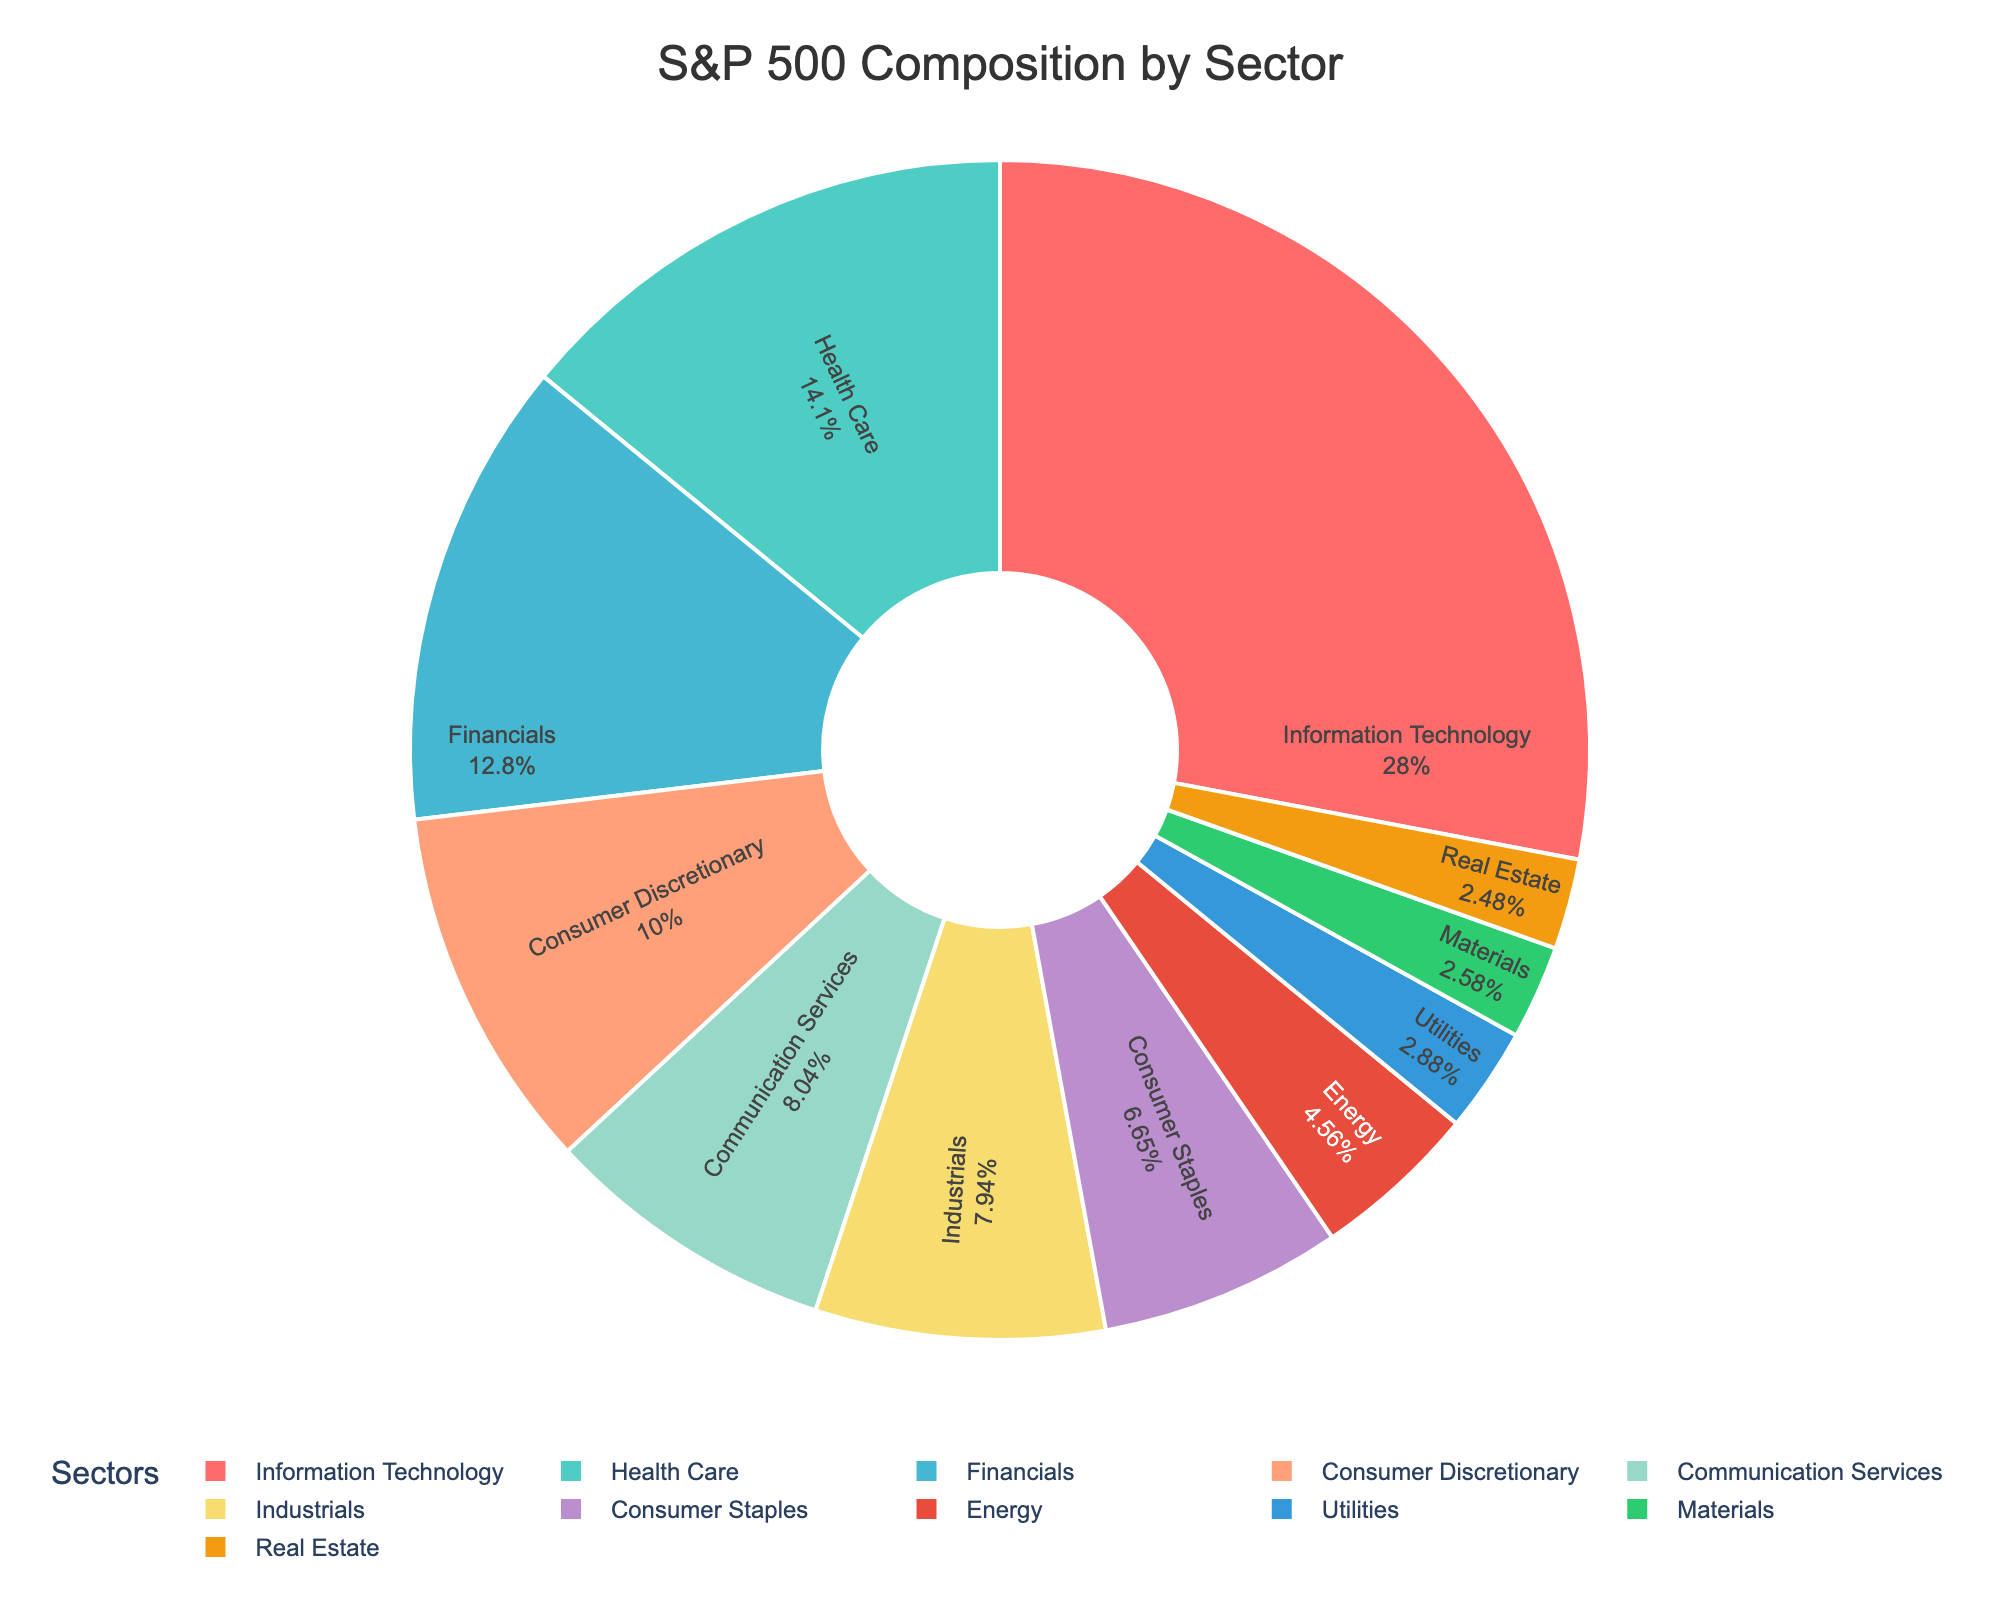What percentage of the S&P 500 is made up by the Utilities and Materials sectors combined? To find the combined percentage, simply add the percentages of the Utilities sector (2.9%) and the Materials sector (2.6%). The calculation is 2.9 + 2.6 = 5.5%.
Answer: 5.5% Which sector has the greatest representation in the S&P 500? By examining the pie chart, the sector with the highest percentage is Information Technology at 28.2%.
Answer: Information Technology How do the percentages of the Health Care and Financials sectors compare? The Health Care sector represents 14.2% while the Financials sector represents 12.9% of the S&P 500. By comparing these two, Health Care has a slightly higher percentage.
Answer: Health Care What is the visual color used for the Consumer Staples sector in the chart? By observing the color shading in the pie chart and cross-referencing the legend, the Consumer Staples sector is depicted in a lighter blue color.
Answer: Lighter blue Is the percentage of the Energy sector less than that of the Consumer Discretionary sector? The percentage of the Energy sector is 4.6%, while the Consumer Discretionary sector is 10.1%. Since 4.6% is less than 10.1%, the Energy sector indeed has a lower percentage.
Answer: Yes Calculate the average percentage of the three smallest sectors in the S&P 500. The three smallest sectors are Materials (2.6%), Real Estate (2.5%), and Utilities (2.9%). To find the average, use the formula: (2.6 + 2.5 + 2.9) / 3 = 8 / 3 = 2.67%.
Answer: 2.67% How much larger is the representation of the Information Technology sector compared to the Energy sector? The percentage for Information Technology is 28.2% and for Energy is 4.6%. To find the difference, subtract 4.6 from 28.2: 28.2 - 4.6 = 23.6%.
Answer: 23.6% Among the sectors presented, which sector is second largest, and what is its percentage? The second largest sector after Information Technology is Health Care, which represents 14.2% of the S&P 500.
Answer: Health Care, 14.2% What color is used to represent the Financials sector in the pie chart? By cross-referencing the legend in the pie chart, the Financials sector is depicted in a green-teal color.
Answer: Green-teal 